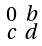Convert formula to latex. <formula><loc_0><loc_0><loc_500><loc_500>\begin{smallmatrix} 0 & b \\ c & d \end{smallmatrix}</formula> 